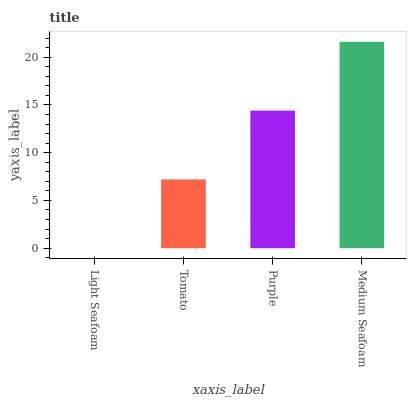Is Tomato the minimum?
Answer yes or no. No. Is Tomato the maximum?
Answer yes or no. No. Is Tomato greater than Light Seafoam?
Answer yes or no. Yes. Is Light Seafoam less than Tomato?
Answer yes or no. Yes. Is Light Seafoam greater than Tomato?
Answer yes or no. No. Is Tomato less than Light Seafoam?
Answer yes or no. No. Is Purple the high median?
Answer yes or no. Yes. Is Tomato the low median?
Answer yes or no. Yes. Is Tomato the high median?
Answer yes or no. No. Is Medium Seafoam the low median?
Answer yes or no. No. 